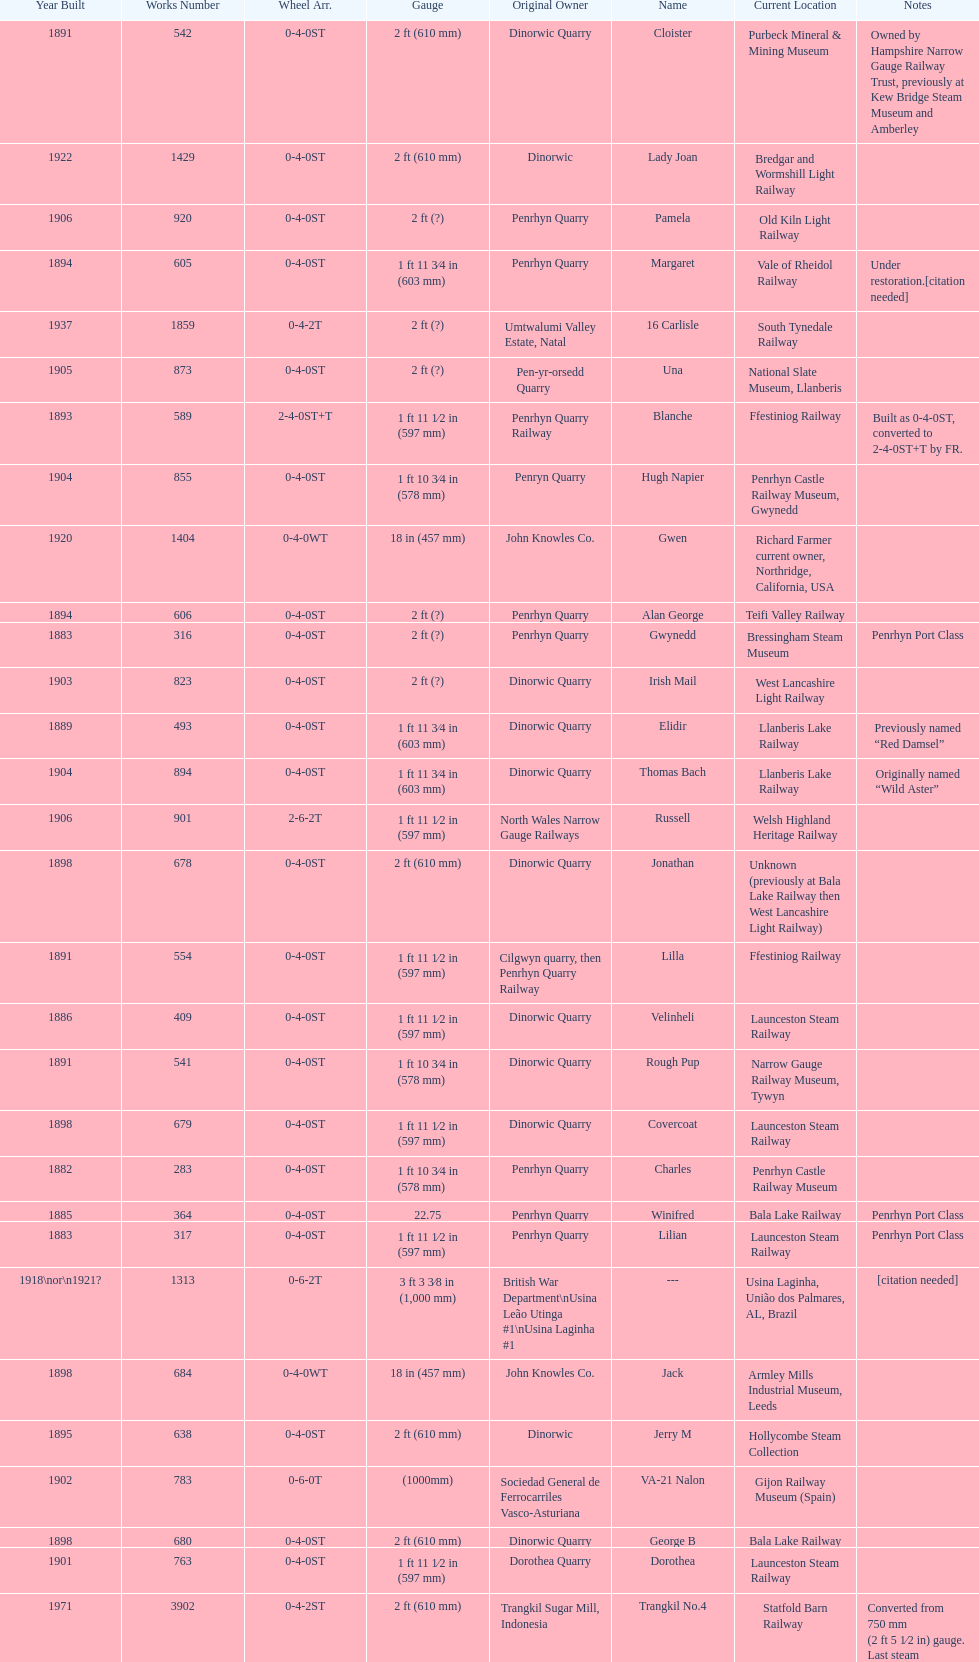What is the name of the last locomotive to be located at the bressingham steam museum? Gwynedd. Would you mind parsing the complete table? {'header': ['Year Built', 'Works Number', 'Wheel Arr.', 'Gauge', 'Original Owner', 'Name', 'Current Location', 'Notes'], 'rows': [['1891', '542', '0-4-0ST', '2\xa0ft (610\xa0mm)', 'Dinorwic Quarry', 'Cloister', 'Purbeck Mineral & Mining Museum', 'Owned by Hampshire Narrow Gauge Railway Trust, previously at Kew Bridge Steam Museum and Amberley'], ['1922', '1429', '0-4-0ST', '2\xa0ft (610\xa0mm)', 'Dinorwic', 'Lady Joan', 'Bredgar and Wormshill Light Railway', ''], ['1906', '920', '0-4-0ST', '2\xa0ft (?)', 'Penrhyn Quarry', 'Pamela', 'Old Kiln Light Railway', ''], ['1894', '605', '0-4-0ST', '1\xa0ft 11\xa03⁄4\xa0in (603\xa0mm)', 'Penrhyn Quarry', 'Margaret', 'Vale of Rheidol Railway', 'Under restoration.[citation needed]'], ['1937', '1859', '0-4-2T', '2\xa0ft (?)', 'Umtwalumi Valley Estate, Natal', '16 Carlisle', 'South Tynedale Railway', ''], ['1905', '873', '0-4-0ST', '2\xa0ft (?)', 'Pen-yr-orsedd Quarry', 'Una', 'National Slate Museum, Llanberis', ''], ['1893', '589', '2-4-0ST+T', '1\xa0ft 11\xa01⁄2\xa0in (597\xa0mm)', 'Penrhyn Quarry Railway', 'Blanche', 'Ffestiniog Railway', 'Built as 0-4-0ST, converted to 2-4-0ST+T by FR.'], ['1904', '855', '0-4-0ST', '1\xa0ft 10\xa03⁄4\xa0in (578\xa0mm)', 'Penryn Quarry', 'Hugh Napier', 'Penrhyn Castle Railway Museum, Gwynedd', ''], ['1920', '1404', '0-4-0WT', '18\xa0in (457\xa0mm)', 'John Knowles Co.', 'Gwen', 'Richard Farmer current owner, Northridge, California, USA', ''], ['1894', '606', '0-4-0ST', '2\xa0ft (?)', 'Penrhyn Quarry', 'Alan George', 'Teifi Valley Railway', ''], ['1883', '316', '0-4-0ST', '2\xa0ft (?)', 'Penrhyn Quarry', 'Gwynedd', 'Bressingham Steam Museum', 'Penrhyn Port Class'], ['1903', '823', '0-4-0ST', '2\xa0ft (?)', 'Dinorwic Quarry', 'Irish Mail', 'West Lancashire Light Railway', ''], ['1889', '493', '0-4-0ST', '1\xa0ft 11\xa03⁄4\xa0in (603\xa0mm)', 'Dinorwic Quarry', 'Elidir', 'Llanberis Lake Railway', 'Previously named “Red Damsel”'], ['1904', '894', '0-4-0ST', '1\xa0ft 11\xa03⁄4\xa0in (603\xa0mm)', 'Dinorwic Quarry', 'Thomas Bach', 'Llanberis Lake Railway', 'Originally named “Wild Aster”'], ['1906', '901', '2-6-2T', '1\xa0ft 11\xa01⁄2\xa0in (597\xa0mm)', 'North Wales Narrow Gauge Railways', 'Russell', 'Welsh Highland Heritage Railway', ''], ['1898', '678', '0-4-0ST', '2\xa0ft (610\xa0mm)', 'Dinorwic Quarry', 'Jonathan', 'Unknown (previously at Bala Lake Railway then West Lancashire Light Railway)', ''], ['1891', '554', '0-4-0ST', '1\xa0ft 11\xa01⁄2\xa0in (597\xa0mm)', 'Cilgwyn quarry, then Penrhyn Quarry Railway', 'Lilla', 'Ffestiniog Railway', ''], ['1886', '409', '0-4-0ST', '1\xa0ft 11\xa01⁄2\xa0in (597\xa0mm)', 'Dinorwic Quarry', 'Velinheli', 'Launceston Steam Railway', ''], ['1891', '541', '0-4-0ST', '1\xa0ft 10\xa03⁄4\xa0in (578\xa0mm)', 'Dinorwic Quarry', 'Rough Pup', 'Narrow Gauge Railway Museum, Tywyn', ''], ['1898', '679', '0-4-0ST', '1\xa0ft 11\xa01⁄2\xa0in (597\xa0mm)', 'Dinorwic Quarry', 'Covercoat', 'Launceston Steam Railway', ''], ['1882', '283', '0-4-0ST', '1\xa0ft 10\xa03⁄4\xa0in (578\xa0mm)', 'Penrhyn Quarry', 'Charles', 'Penrhyn Castle Railway Museum', ''], ['1885', '364', '0-4-0ST', '22.75', 'Penrhyn Quarry', 'Winifred', 'Bala Lake Railway', 'Penrhyn Port Class'], ['1883', '317', '0-4-0ST', '1\xa0ft 11\xa01⁄2\xa0in (597\xa0mm)', 'Penrhyn Quarry', 'Lilian', 'Launceston Steam Railway', 'Penrhyn Port Class'], ['1918\\nor\\n1921?', '1313', '0-6-2T', '3\xa0ft\xa03\xa03⁄8\xa0in (1,000\xa0mm)', 'British War Department\\nUsina Leão Utinga #1\\nUsina Laginha #1', '---', 'Usina Laginha, União dos Palmares, AL, Brazil', '[citation needed]'], ['1898', '684', '0-4-0WT', '18\xa0in (457\xa0mm)', 'John Knowles Co.', 'Jack', 'Armley Mills Industrial Museum, Leeds', ''], ['1895', '638', '0-4-0ST', '2\xa0ft (610\xa0mm)', 'Dinorwic', 'Jerry M', 'Hollycombe Steam Collection', ''], ['1902', '783', '0-6-0T', '(1000mm)', 'Sociedad General de Ferrocarriles Vasco-Asturiana', 'VA-21 Nalon', 'Gijon Railway Museum (Spain)', ''], ['1898', '680', '0-4-0ST', '2\xa0ft (610\xa0mm)', 'Dinorwic Quarry', 'George B', 'Bala Lake Railway', ''], ['1901', '763', '0-4-0ST', '1\xa0ft 11\xa01⁄2\xa0in (597\xa0mm)', 'Dorothea Quarry', 'Dorothea', 'Launceston Steam Railway', ''], ['1971', '3902', '0-4-2ST', '2\xa0ft (610\xa0mm)', 'Trangkil Sugar Mill, Indonesia', 'Trangkil No.4', 'Statfold Barn Railway', 'Converted from 750\xa0mm (2\xa0ft\xa05\xa01⁄2\xa0in) gauge. Last steam locomotive to be built by Hunslet, and the last industrial steam locomotive built in Britain.'], ['1899', '705', '0-4-0ST', '2\xa0ft (610\xa0mm)', 'Penrhyn Quarry', 'Elin', 'Yaxham Light Railway', 'Previously at the Lincolnshire Coast Light Railway.'], ['1903', '827', '0-4-0ST', '1\xa0ft 11\xa03⁄4\xa0in (603\xa0mm)', 'Pen-yr-orsedd Quarry', 'Sybil', 'Brecon Mountain Railway', ''], ['1893', '590', '2-4-0ST+T', '1\xa0ft 11\xa01⁄2\xa0in (597\xa0mm)', 'Penrhyn Quarry Railway', 'Linda', 'Ffestiniog Railway', 'Built as 0-4-0ST, converted to 2-4-0ST+T by FR.'], ['1954', '3815', '2-6-2T', '2\xa0ft 6\xa0in (762\xa0mm)', 'Sierra Leone Government Railway', '14', 'Welshpool and Llanfair Light Railway', ''], ['1899', '707', '0-4-0ST', '1\xa0ft 11\xa01⁄2\xa0in (597\xa0mm)', 'Pen-yr-orsedd Quarry', 'Britomart', 'Ffestiniog Railway', ''], ['1902', '779', '0-4-0ST', '2\xa0ft (610\xa0mm)', 'Dinorwic Quarry', 'Holy War', 'Bala Lake Railway', ''], ['1903', '822', '0-4-0ST', '2\xa0ft (610\xa0mm)', 'Dinorwic Quarry', 'Maid Marian', 'Bala Lake Railway', ''], ['1890', '518', '2-2-0T', '(1000mm)', 'S.V.T. 8', 'Tortosa-La Cava1', 'Tortosa (catalonia, Spain)', ''], ['1918', '1312', '4-6-0T', '1\xa0ft\xa011\xa01⁄2\xa0in (597\xa0mm)', 'British War Department\\nEFOP #203', '---', 'Pampas Safari, Gravataí, RS, Brazil', '[citation needed]'], ['1922', '1430', '0-4-0ST', '1\xa0ft 11\xa03⁄4\xa0in (603\xa0mm)', 'Dinorwic Quarry', 'Dolbadarn', 'Llanberis Lake Railway', ''], ['1940', '2075', '0-4-2T', '2\xa0ft (?)', 'Chaka’s Kraal Sugar Estates, Natal', 'Chaka’s Kraal No. 6', 'North Gloucestershire Railway', ''], ['1909', '994', '0-4-0ST', '2\xa0ft (?)', 'Penrhyn Quarry', 'Bill Harvey', 'Bressingham Steam Museum', 'previously George Sholto'], ['1902', '780', '0-4-0ST', '2\xa0ft (610\xa0mm)', 'Dinorwic Quarry', 'Alice', 'Bala Lake Railway', ''], ['1896', '652', '0-4-0ST', '1\xa0ft 11\xa01⁄2\xa0in (597\xa0mm)', 'Groby Granite, then Dinorwic Quarry', 'Lady Madcap', 'Welsh Highland Heritage Railway', 'Originally named Sextus.']]} 